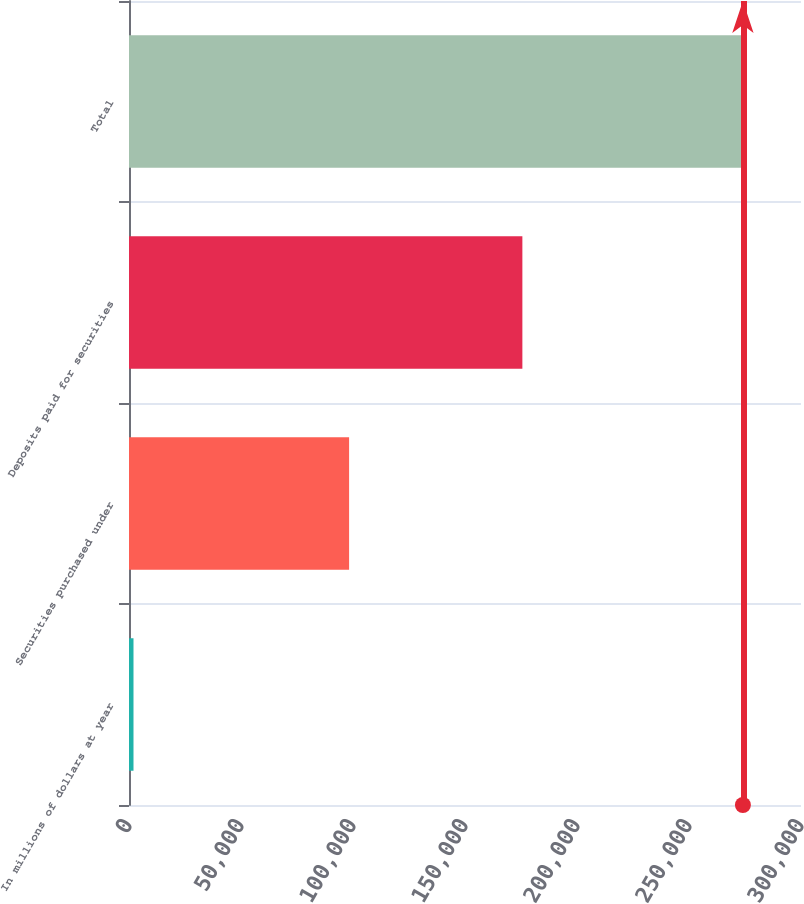Convert chart to OTSL. <chart><loc_0><loc_0><loc_500><loc_500><bar_chart><fcel>In millions of dollars at year<fcel>Securities purchased under<fcel>Deposits paid for securities<fcel>Total<nl><fcel>2007<fcel>98258<fcel>175612<fcel>274066<nl></chart> 